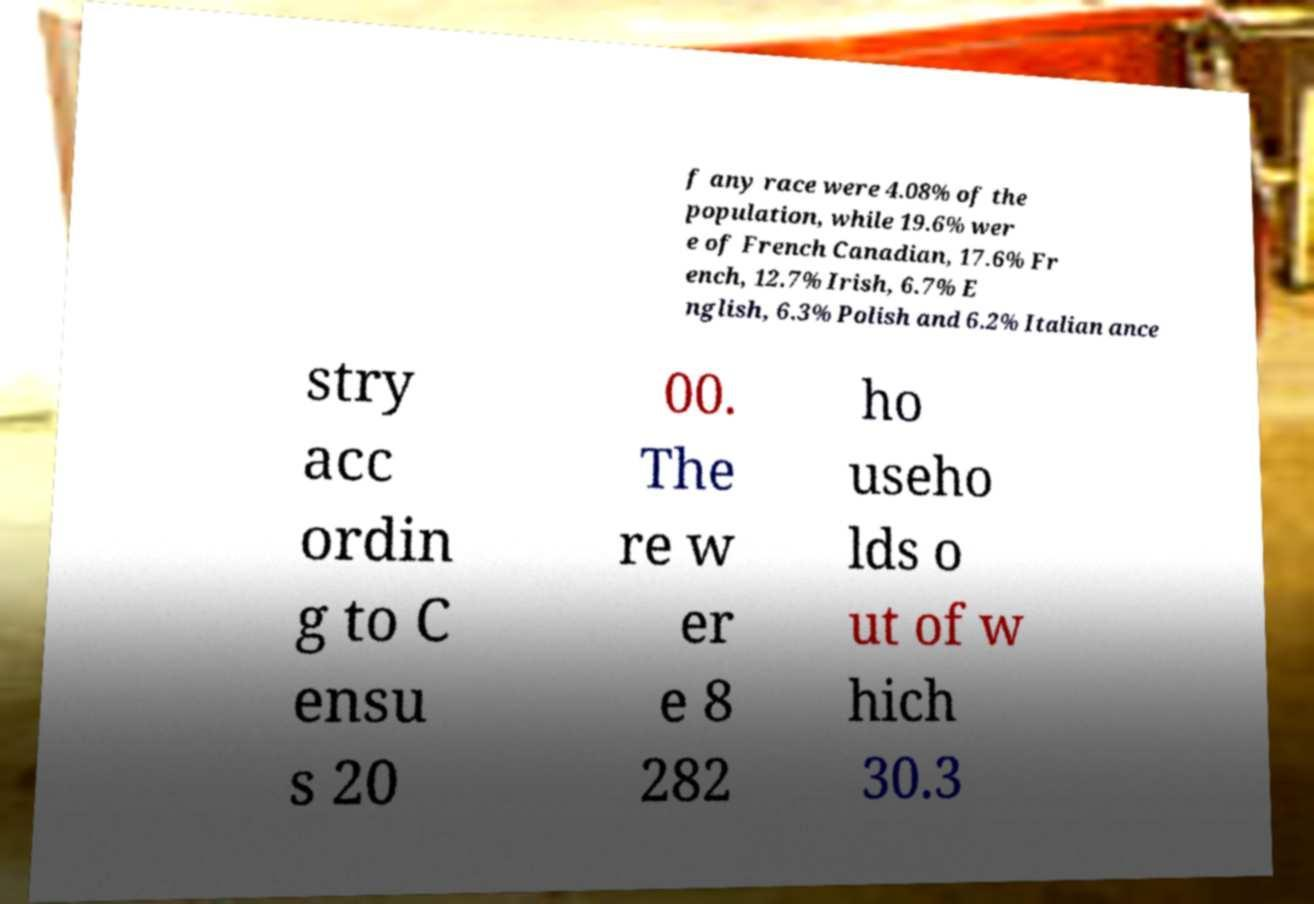Could you extract and type out the text from this image? f any race were 4.08% of the population, while 19.6% wer e of French Canadian, 17.6% Fr ench, 12.7% Irish, 6.7% E nglish, 6.3% Polish and 6.2% Italian ance stry acc ordin g to C ensu s 20 00. The re w er e 8 282 ho useho lds o ut of w hich 30.3 